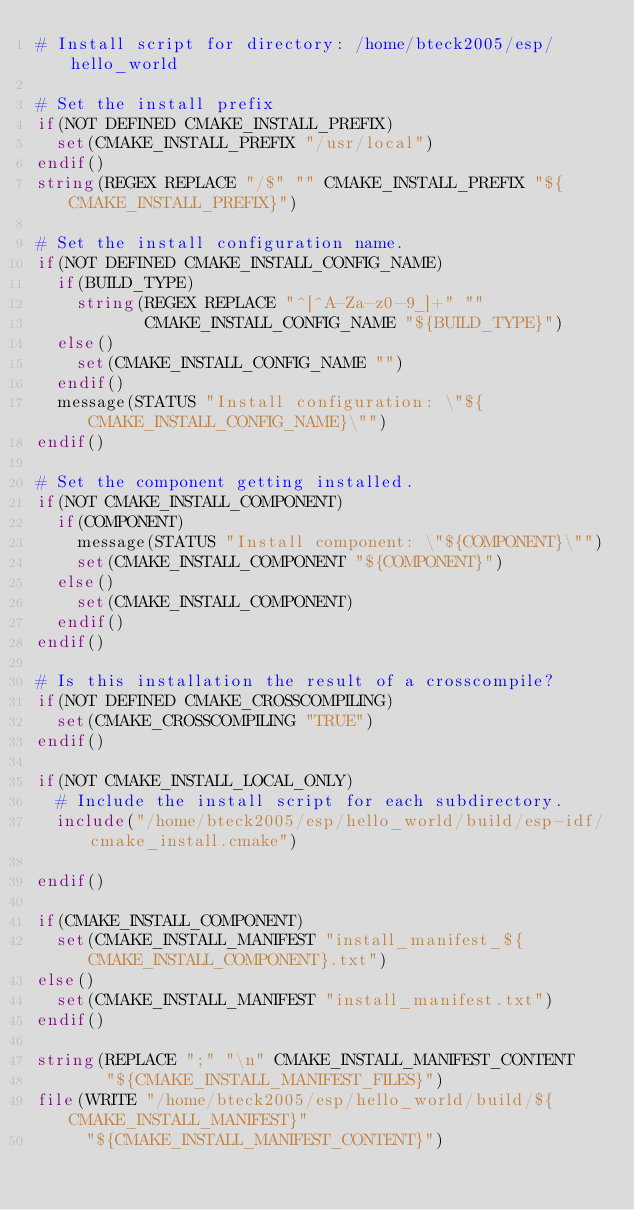Convert code to text. <code><loc_0><loc_0><loc_500><loc_500><_CMake_># Install script for directory: /home/bteck2005/esp/hello_world

# Set the install prefix
if(NOT DEFINED CMAKE_INSTALL_PREFIX)
  set(CMAKE_INSTALL_PREFIX "/usr/local")
endif()
string(REGEX REPLACE "/$" "" CMAKE_INSTALL_PREFIX "${CMAKE_INSTALL_PREFIX}")

# Set the install configuration name.
if(NOT DEFINED CMAKE_INSTALL_CONFIG_NAME)
  if(BUILD_TYPE)
    string(REGEX REPLACE "^[^A-Za-z0-9_]+" ""
           CMAKE_INSTALL_CONFIG_NAME "${BUILD_TYPE}")
  else()
    set(CMAKE_INSTALL_CONFIG_NAME "")
  endif()
  message(STATUS "Install configuration: \"${CMAKE_INSTALL_CONFIG_NAME}\"")
endif()

# Set the component getting installed.
if(NOT CMAKE_INSTALL_COMPONENT)
  if(COMPONENT)
    message(STATUS "Install component: \"${COMPONENT}\"")
    set(CMAKE_INSTALL_COMPONENT "${COMPONENT}")
  else()
    set(CMAKE_INSTALL_COMPONENT)
  endif()
endif()

# Is this installation the result of a crosscompile?
if(NOT DEFINED CMAKE_CROSSCOMPILING)
  set(CMAKE_CROSSCOMPILING "TRUE")
endif()

if(NOT CMAKE_INSTALL_LOCAL_ONLY)
  # Include the install script for each subdirectory.
  include("/home/bteck2005/esp/hello_world/build/esp-idf/cmake_install.cmake")

endif()

if(CMAKE_INSTALL_COMPONENT)
  set(CMAKE_INSTALL_MANIFEST "install_manifest_${CMAKE_INSTALL_COMPONENT}.txt")
else()
  set(CMAKE_INSTALL_MANIFEST "install_manifest.txt")
endif()

string(REPLACE ";" "\n" CMAKE_INSTALL_MANIFEST_CONTENT
       "${CMAKE_INSTALL_MANIFEST_FILES}")
file(WRITE "/home/bteck2005/esp/hello_world/build/${CMAKE_INSTALL_MANIFEST}"
     "${CMAKE_INSTALL_MANIFEST_CONTENT}")
</code> 